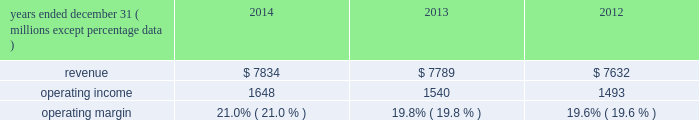Equity equity at december 31 , 2014 was $ 6.6 billion , a decrease of $ 1.6 billion from december 31 , 2013 .
The decrease resulted primarily due to share repurchases of $ 2.3 billion , $ 273 million of dividends to shareholders , and an increase in accumulated other comprehensive loss of $ 760 million , partially offset by net income of $ 1.4 billion .
The $ 760 million increase in accumulated other comprehensive loss from december 31 , 2013 , primarily reflects the following : 2022 negative net foreign currency translation adjustments of $ 504 million , which are attributable to the strengthening of the u.s .
Dollar against certain foreign currencies , 2022 an increase of $ 260 million in net post-retirement benefit obligations , 2022 net derivative gains of $ 5 million , and 2022 net investment losses of $ 1 million .
Review by segment general we serve clients through the following segments : 2022 risk solutions acts as an advisor and insurance and reinsurance broker , helping clients manage their risks , via consultation , as well as negotiation and placement of insurance risk with insurance carriers through our global distribution network .
2022 hr solutions partners with organizations to solve their most complex benefits , talent and related financial challenges , and improve business performance by designing , implementing , communicating and administering a wide range of human capital , retirement , investment management , health care , compensation and talent management strategies .
Risk solutions .
The demand for property and casualty insurance generally rises as the overall level of economic activity increases and generally falls as such activity decreases , affecting both the commissions and fees generated by our brokerage business .
The economic activity that impacts property and casualty insurance is described as exposure units , and is most closely correlated with employment levels , corporate revenue and asset values .
During 2014 , pricing was flat on average globally , and we would still consider this to be a "soft market." in a soft market , premium rates flatten or decrease , along with commission revenues , due to increased competition for market share among insurance carriers or increased underwriting capacity .
Changes in premiums have a direct and potentially material impact on the insurance brokerage industry , as commission revenues are generally based on a percentage of the premiums paid by insureds .
Additionally , continuing through 2014 , we faced difficult conditions as a result of continued weakness in the global economy , the repricing of credit risk and the deterioration of the financial markets .
Weak economic conditions in many markets around the globe have reduced our customers' demand for our retail brokerage and reinsurance brokerage products , which have had a negative impact on our operational results .
Risk solutions generated approximately 65% ( 65 % ) of our consolidated total revenues in 2014 .
Revenues are generated primarily through fees paid by clients , commissions and fees paid by insurance and reinsurance companies , and investment income on funds held on behalf of clients .
Our revenues vary from quarter to quarter throughout the year as a result of the timing of our clients' policy renewals , the net effect of new and lost business , the timing of services provided to our clients , and the income we earn on investments , which is heavily influenced by short-term interest rates .
We operate in a highly competitive industry and compete with many retail insurance brokerage and agency firms , as well as with individual brokers , agents , and direct writers of insurance coverage .
Specifically , we address the highly specialized .
What is the growth rate of the operating income from 2013 to 2014? 
Computations: ((1648 - 1540) / 1540)
Answer: 0.07013. 